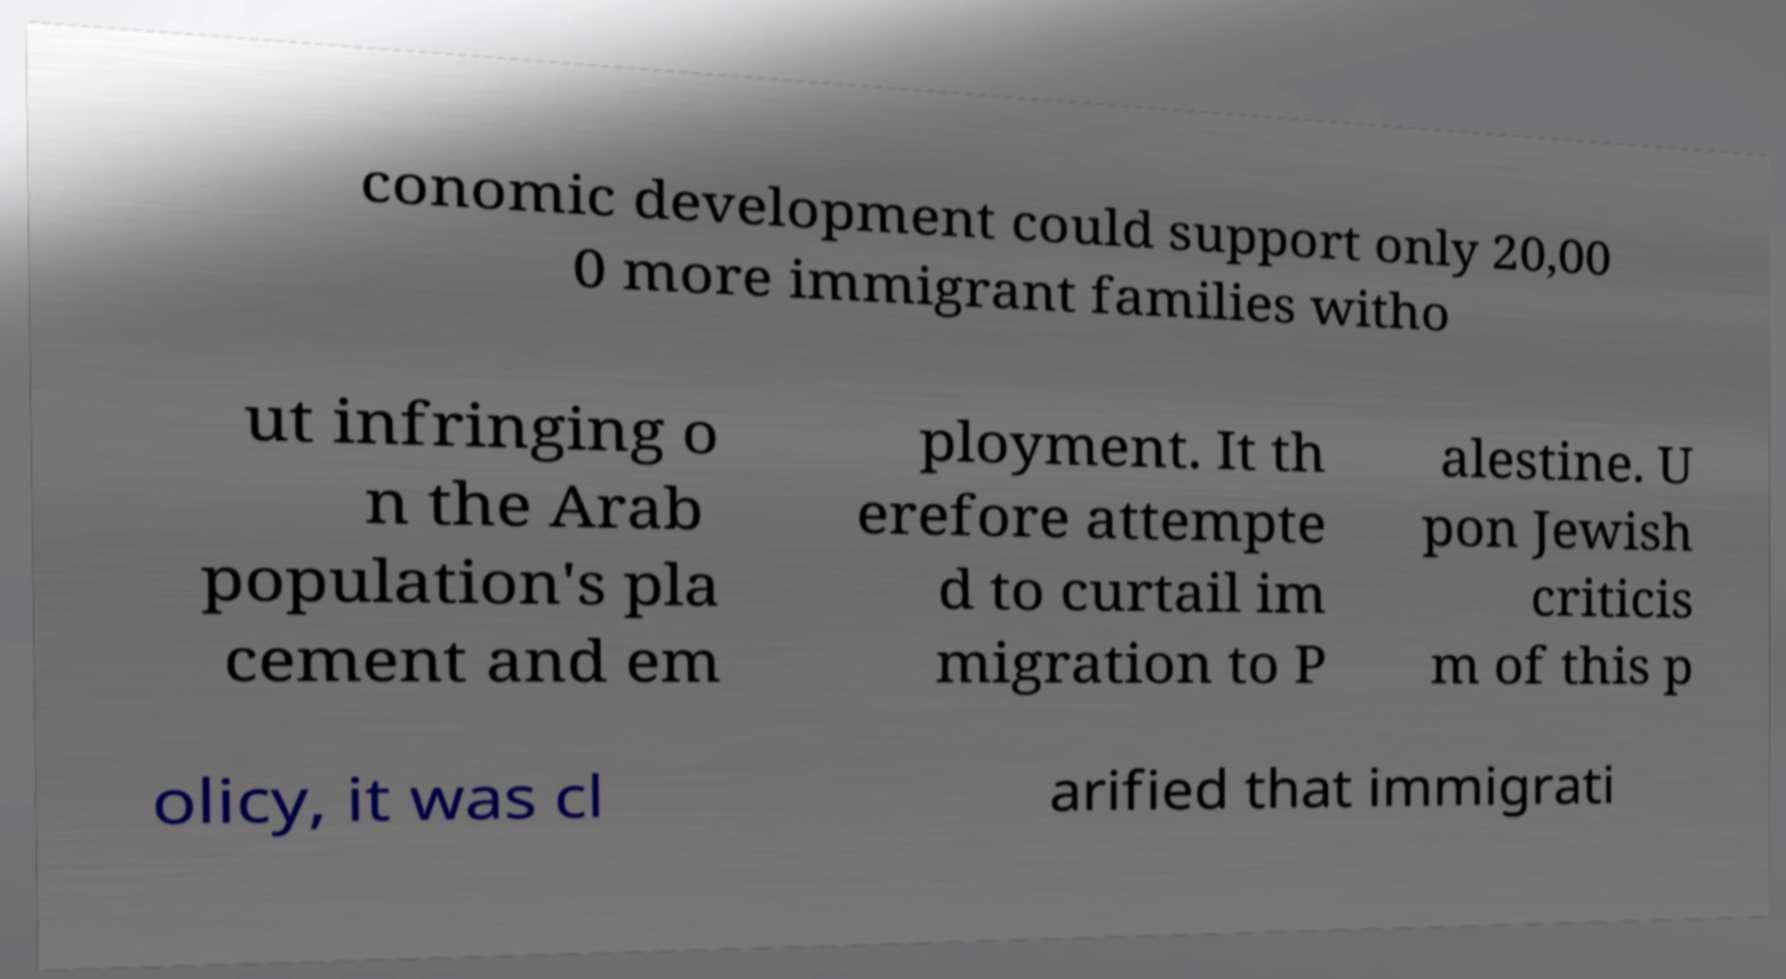Can you accurately transcribe the text from the provided image for me? conomic development could support only 20,00 0 more immigrant families witho ut infringing o n the Arab population's pla cement and em ployment. It th erefore attempte d to curtail im migration to P alestine. U pon Jewish criticis m of this p olicy, it was cl arified that immigrati 